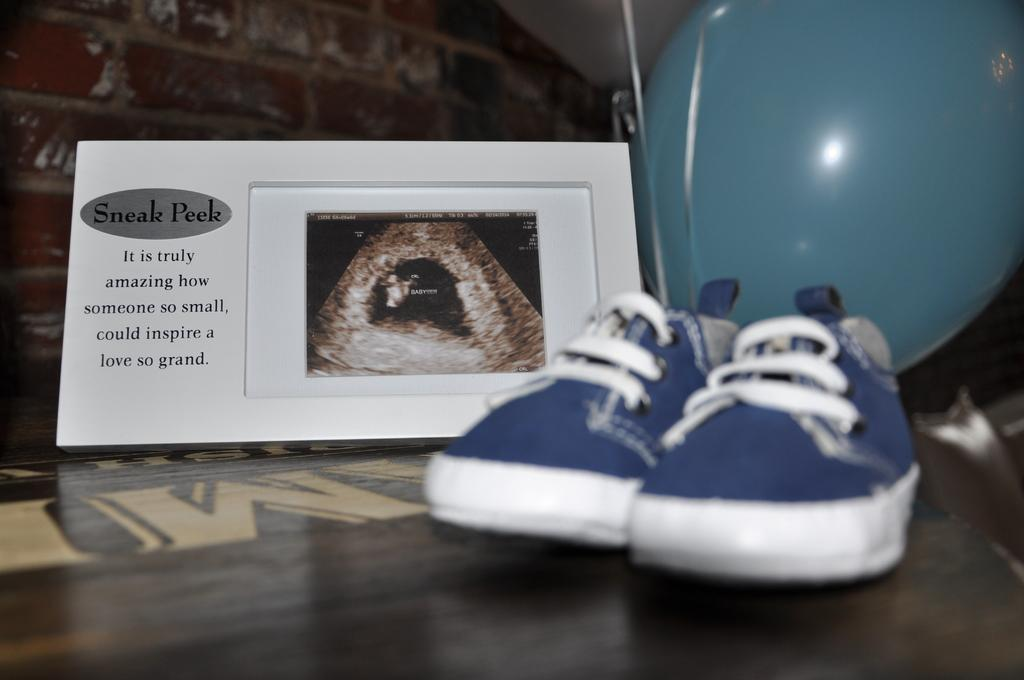What type of objects can be seen in the image? There are shoes, a photo frame with text, and a balloon in the image. What is inside the photo frame? There is a photo in the photo frame. Can you describe the text on the photo frame? Unfortunately, the facts provided do not give information about the text on the photo frame. What is the purpose of the balloon in the image? The purpose of the balloon in the image cannot be determined from the provided facts. What type of dog is sitting next to the shoes in the image? There is no dog present in the image; only shoes, a photo frame, and a balloon are visible. 